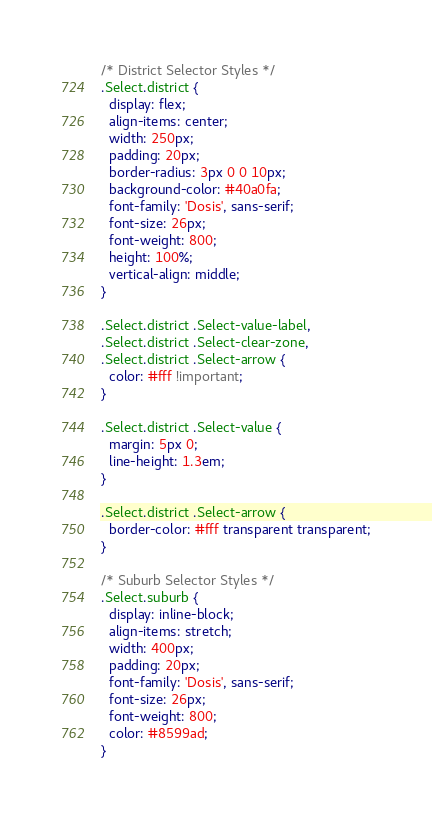Convert code to text. <code><loc_0><loc_0><loc_500><loc_500><_CSS_>/* District Selector Styles */
.Select.district {
  display: flex;
  align-items: center;
  width: 250px;
  padding: 20px;
  border-radius: 3px 0 0 10px;
  background-color: #40a0fa;
  font-family: 'Dosis', sans-serif;
  font-size: 26px;
  font-weight: 800;
  height: 100%;
  vertical-align: middle;
}

.Select.district .Select-value-label,
.Select.district .Select-clear-zone,
.Select.district .Select-arrow {
  color: #fff !important;
}

.Select.district .Select-value {
  margin: 5px 0;
  line-height: 1.3em;
}

.Select.district .Select-arrow {
  border-color: #fff transparent transparent;
}

/* Suburb Selector Styles */
.Select.suburb {
  display: inline-block;
  align-items: stretch;
  width: 400px;
  padding: 20px;
  font-family: 'Dosis', sans-serif;
  font-size: 26px;
  font-weight: 800;
  color: #8599ad;
}
</code> 